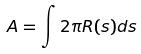<formula> <loc_0><loc_0><loc_500><loc_500>A = \int 2 \pi R ( s ) d s</formula> 